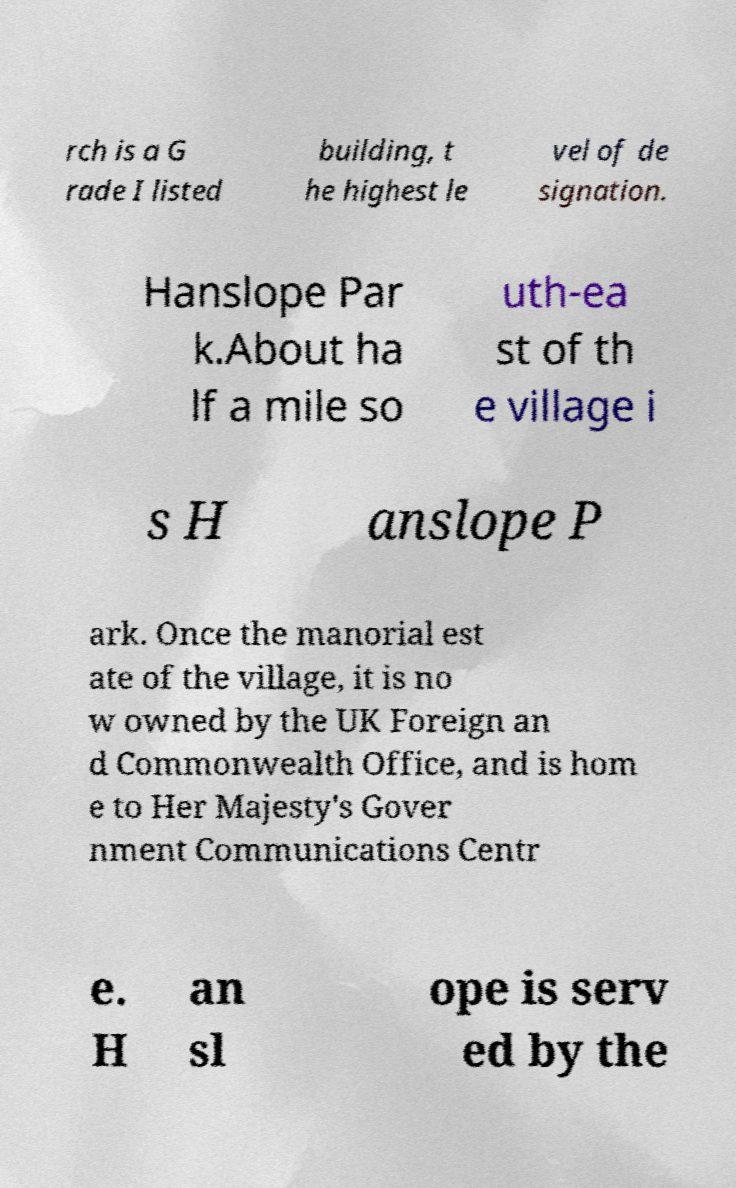Can you accurately transcribe the text from the provided image for me? rch is a G rade I listed building, t he highest le vel of de signation. Hanslope Par k.About ha lf a mile so uth-ea st of th e village i s H anslope P ark. Once the manorial est ate of the village, it is no w owned by the UK Foreign an d Commonwealth Office, and is hom e to Her Majesty's Gover nment Communications Centr e. H an sl ope is serv ed by the 